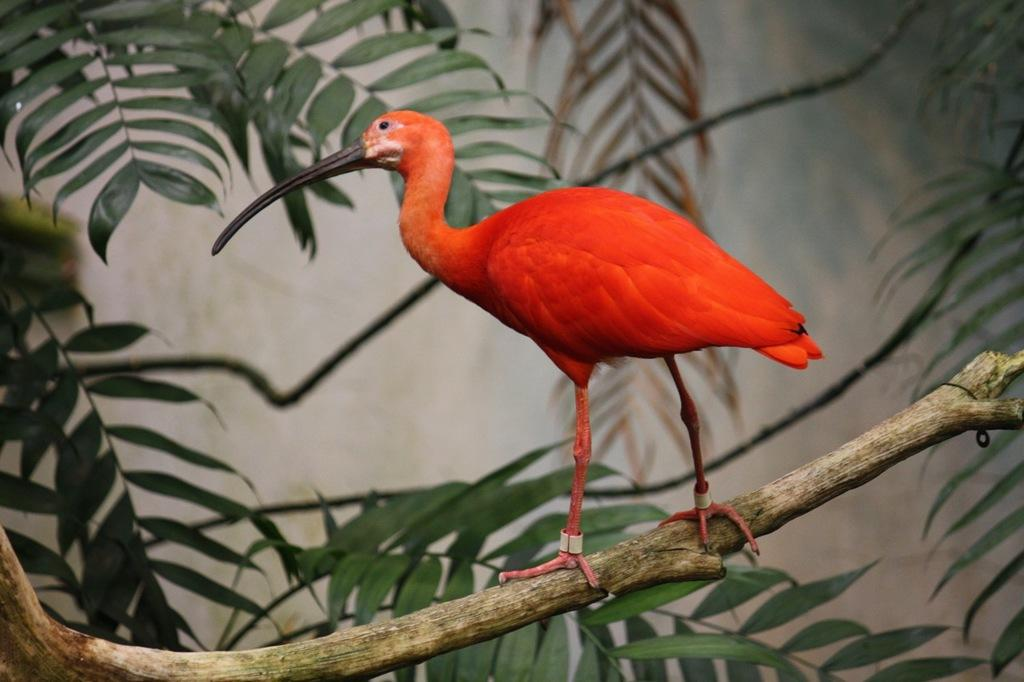What type of bird can be seen in the image? There is a red color bird in the image. Where is the bird located? The bird is standing on a tree branch. What can be seen at the bottom of the image? Leaves are visible at the bottom of the image. What is located on the right side of the image? There is a plant near a wall on the right side of the image. What attempt is the bird making to sail in the image? There is no attempt to sail in the image, as the bird is standing on a tree branch and not on water. 